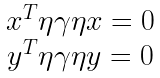<formula> <loc_0><loc_0><loc_500><loc_500>\begin{array} { c } x ^ { T } \eta \gamma \eta x = 0 \\ y ^ { T } \eta \gamma \eta y = 0 \end{array}</formula> 